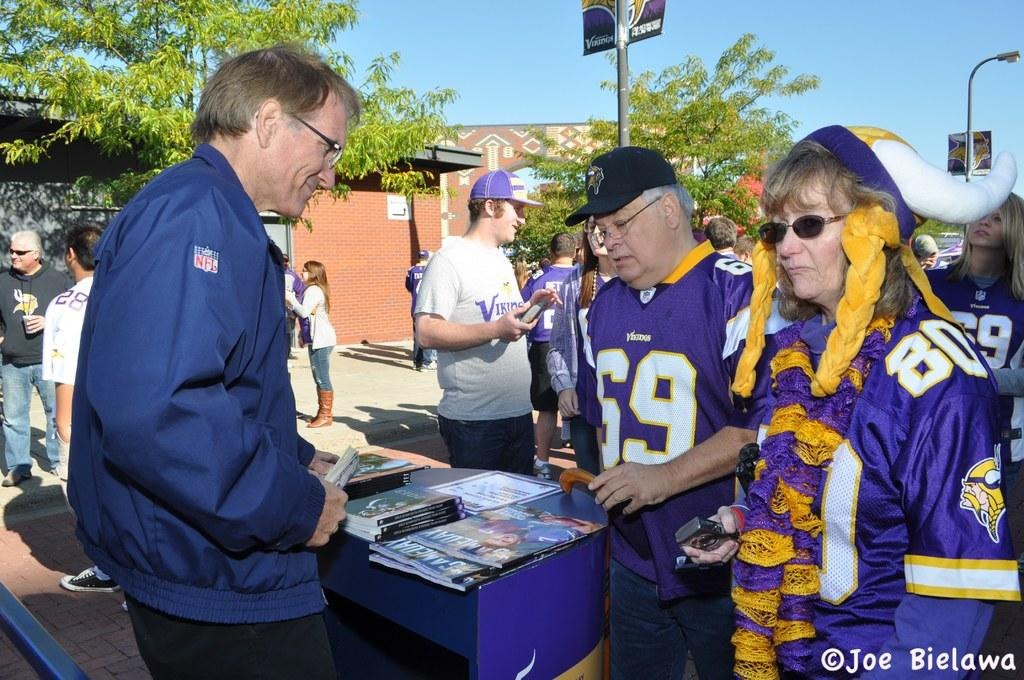<image>
Relay a brief, clear account of the picture shown. People wearing Minnesota Vikings jerseys look at items being sold by a man wearing an NFL jacket. 